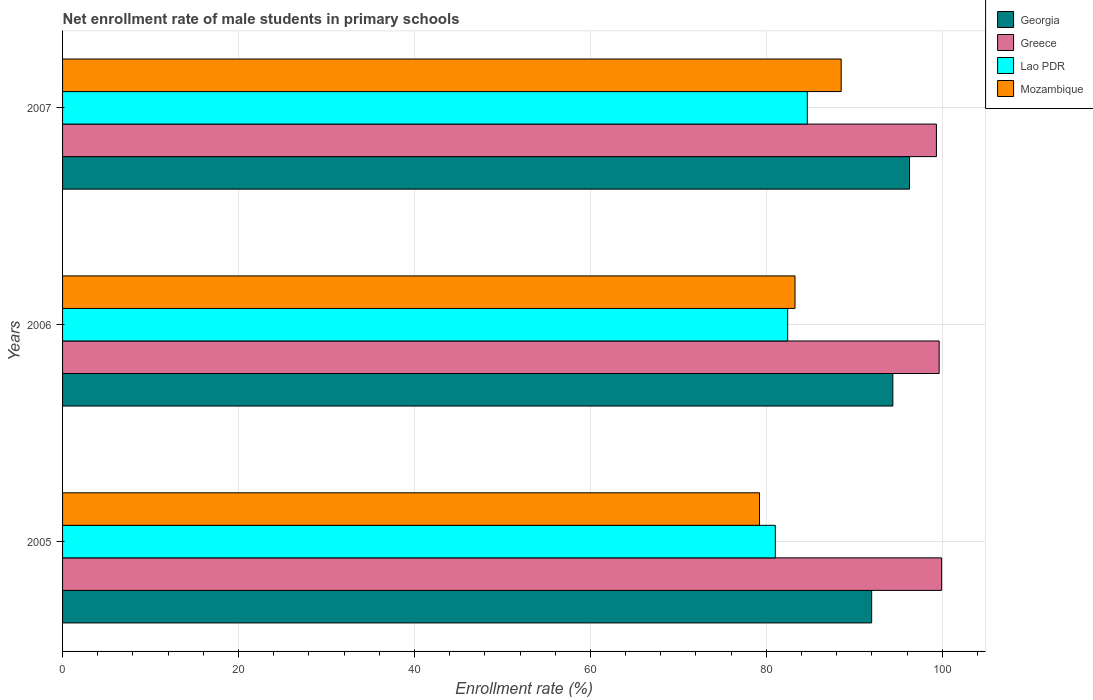How many different coloured bars are there?
Provide a succinct answer. 4. How many bars are there on the 1st tick from the bottom?
Your answer should be very brief. 4. What is the net enrollment rate of male students in primary schools in Mozambique in 2005?
Offer a very short reply. 79.22. Across all years, what is the maximum net enrollment rate of male students in primary schools in Lao PDR?
Your answer should be compact. 84.66. Across all years, what is the minimum net enrollment rate of male students in primary schools in Georgia?
Offer a very short reply. 91.97. In which year was the net enrollment rate of male students in primary schools in Lao PDR maximum?
Your answer should be very brief. 2007. In which year was the net enrollment rate of male students in primary schools in Mozambique minimum?
Your response must be concise. 2005. What is the total net enrollment rate of male students in primary schools in Mozambique in the graph?
Ensure brevity in your answer.  250.99. What is the difference between the net enrollment rate of male students in primary schools in Greece in 2005 and that in 2007?
Keep it short and to the point. 0.59. What is the difference between the net enrollment rate of male students in primary schools in Georgia in 2006 and the net enrollment rate of male students in primary schools in Lao PDR in 2007?
Your response must be concise. 9.72. What is the average net enrollment rate of male students in primary schools in Georgia per year?
Your answer should be compact. 94.21. In the year 2005, what is the difference between the net enrollment rate of male students in primary schools in Lao PDR and net enrollment rate of male students in primary schools in Greece?
Keep it short and to the point. -18.91. What is the ratio of the net enrollment rate of male students in primary schools in Mozambique in 2005 to that in 2007?
Keep it short and to the point. 0.9. Is the net enrollment rate of male students in primary schools in Mozambique in 2006 less than that in 2007?
Provide a succinct answer. Yes. What is the difference between the highest and the second highest net enrollment rate of male students in primary schools in Georgia?
Offer a very short reply. 1.9. What is the difference between the highest and the lowest net enrollment rate of male students in primary schools in Georgia?
Your answer should be very brief. 4.31. In how many years, is the net enrollment rate of male students in primary schools in Greece greater than the average net enrollment rate of male students in primary schools in Greece taken over all years?
Provide a short and direct response. 2. Is the sum of the net enrollment rate of male students in primary schools in Georgia in 2005 and 2006 greater than the maximum net enrollment rate of male students in primary schools in Lao PDR across all years?
Provide a succinct answer. Yes. What does the 1st bar from the top in 2007 represents?
Offer a very short reply. Mozambique. What does the 4th bar from the bottom in 2005 represents?
Your answer should be compact. Mozambique. How many bars are there?
Ensure brevity in your answer.  12. What is the difference between two consecutive major ticks on the X-axis?
Provide a succinct answer. 20. How many legend labels are there?
Offer a very short reply. 4. What is the title of the graph?
Your answer should be compact. Net enrollment rate of male students in primary schools. What is the label or title of the X-axis?
Provide a short and direct response. Enrollment rate (%). What is the Enrollment rate (%) of Georgia in 2005?
Offer a very short reply. 91.97. What is the Enrollment rate (%) of Greece in 2005?
Provide a succinct answer. 99.93. What is the Enrollment rate (%) in Lao PDR in 2005?
Give a very brief answer. 81.02. What is the Enrollment rate (%) of Mozambique in 2005?
Your answer should be compact. 79.22. What is the Enrollment rate (%) of Georgia in 2006?
Provide a succinct answer. 94.38. What is the Enrollment rate (%) of Greece in 2006?
Ensure brevity in your answer.  99.64. What is the Enrollment rate (%) of Lao PDR in 2006?
Give a very brief answer. 82.43. What is the Enrollment rate (%) of Mozambique in 2006?
Offer a very short reply. 83.26. What is the Enrollment rate (%) of Georgia in 2007?
Offer a very short reply. 96.28. What is the Enrollment rate (%) in Greece in 2007?
Your response must be concise. 99.33. What is the Enrollment rate (%) in Lao PDR in 2007?
Offer a very short reply. 84.66. What is the Enrollment rate (%) of Mozambique in 2007?
Your response must be concise. 88.51. Across all years, what is the maximum Enrollment rate (%) of Georgia?
Give a very brief answer. 96.28. Across all years, what is the maximum Enrollment rate (%) in Greece?
Make the answer very short. 99.93. Across all years, what is the maximum Enrollment rate (%) in Lao PDR?
Provide a succinct answer. 84.66. Across all years, what is the maximum Enrollment rate (%) in Mozambique?
Offer a very short reply. 88.51. Across all years, what is the minimum Enrollment rate (%) in Georgia?
Provide a succinct answer. 91.97. Across all years, what is the minimum Enrollment rate (%) of Greece?
Your answer should be compact. 99.33. Across all years, what is the minimum Enrollment rate (%) of Lao PDR?
Provide a succinct answer. 81.02. Across all years, what is the minimum Enrollment rate (%) in Mozambique?
Your answer should be compact. 79.22. What is the total Enrollment rate (%) in Georgia in the graph?
Your response must be concise. 282.63. What is the total Enrollment rate (%) in Greece in the graph?
Keep it short and to the point. 298.9. What is the total Enrollment rate (%) of Lao PDR in the graph?
Provide a short and direct response. 248.11. What is the total Enrollment rate (%) of Mozambique in the graph?
Offer a very short reply. 250.99. What is the difference between the Enrollment rate (%) in Georgia in 2005 and that in 2006?
Your answer should be very brief. -2.41. What is the difference between the Enrollment rate (%) of Greece in 2005 and that in 2006?
Offer a very short reply. 0.28. What is the difference between the Enrollment rate (%) of Lao PDR in 2005 and that in 2006?
Your answer should be very brief. -1.41. What is the difference between the Enrollment rate (%) in Mozambique in 2005 and that in 2006?
Your answer should be compact. -4.04. What is the difference between the Enrollment rate (%) of Georgia in 2005 and that in 2007?
Your answer should be compact. -4.31. What is the difference between the Enrollment rate (%) in Greece in 2005 and that in 2007?
Offer a terse response. 0.59. What is the difference between the Enrollment rate (%) in Lao PDR in 2005 and that in 2007?
Offer a terse response. -3.64. What is the difference between the Enrollment rate (%) in Mozambique in 2005 and that in 2007?
Your response must be concise. -9.28. What is the difference between the Enrollment rate (%) of Georgia in 2006 and that in 2007?
Give a very brief answer. -1.9. What is the difference between the Enrollment rate (%) in Greece in 2006 and that in 2007?
Your answer should be compact. 0.31. What is the difference between the Enrollment rate (%) of Lao PDR in 2006 and that in 2007?
Offer a terse response. -2.23. What is the difference between the Enrollment rate (%) of Mozambique in 2006 and that in 2007?
Provide a succinct answer. -5.25. What is the difference between the Enrollment rate (%) in Georgia in 2005 and the Enrollment rate (%) in Greece in 2006?
Your answer should be compact. -7.67. What is the difference between the Enrollment rate (%) of Georgia in 2005 and the Enrollment rate (%) of Lao PDR in 2006?
Give a very brief answer. 9.54. What is the difference between the Enrollment rate (%) in Georgia in 2005 and the Enrollment rate (%) in Mozambique in 2006?
Your answer should be compact. 8.71. What is the difference between the Enrollment rate (%) in Greece in 2005 and the Enrollment rate (%) in Lao PDR in 2006?
Offer a very short reply. 17.5. What is the difference between the Enrollment rate (%) of Greece in 2005 and the Enrollment rate (%) of Mozambique in 2006?
Provide a short and direct response. 16.67. What is the difference between the Enrollment rate (%) in Lao PDR in 2005 and the Enrollment rate (%) in Mozambique in 2006?
Make the answer very short. -2.24. What is the difference between the Enrollment rate (%) in Georgia in 2005 and the Enrollment rate (%) in Greece in 2007?
Your response must be concise. -7.36. What is the difference between the Enrollment rate (%) in Georgia in 2005 and the Enrollment rate (%) in Lao PDR in 2007?
Make the answer very short. 7.32. What is the difference between the Enrollment rate (%) of Georgia in 2005 and the Enrollment rate (%) of Mozambique in 2007?
Your response must be concise. 3.46. What is the difference between the Enrollment rate (%) of Greece in 2005 and the Enrollment rate (%) of Lao PDR in 2007?
Provide a short and direct response. 15.27. What is the difference between the Enrollment rate (%) in Greece in 2005 and the Enrollment rate (%) in Mozambique in 2007?
Give a very brief answer. 11.42. What is the difference between the Enrollment rate (%) of Lao PDR in 2005 and the Enrollment rate (%) of Mozambique in 2007?
Give a very brief answer. -7.49. What is the difference between the Enrollment rate (%) in Georgia in 2006 and the Enrollment rate (%) in Greece in 2007?
Keep it short and to the point. -4.95. What is the difference between the Enrollment rate (%) of Georgia in 2006 and the Enrollment rate (%) of Lao PDR in 2007?
Offer a very short reply. 9.72. What is the difference between the Enrollment rate (%) in Georgia in 2006 and the Enrollment rate (%) in Mozambique in 2007?
Provide a succinct answer. 5.87. What is the difference between the Enrollment rate (%) of Greece in 2006 and the Enrollment rate (%) of Lao PDR in 2007?
Provide a succinct answer. 14.99. What is the difference between the Enrollment rate (%) in Greece in 2006 and the Enrollment rate (%) in Mozambique in 2007?
Offer a terse response. 11.13. What is the difference between the Enrollment rate (%) in Lao PDR in 2006 and the Enrollment rate (%) in Mozambique in 2007?
Your response must be concise. -6.08. What is the average Enrollment rate (%) in Georgia per year?
Provide a short and direct response. 94.21. What is the average Enrollment rate (%) of Greece per year?
Ensure brevity in your answer.  99.63. What is the average Enrollment rate (%) in Lao PDR per year?
Offer a very short reply. 82.7. What is the average Enrollment rate (%) of Mozambique per year?
Offer a terse response. 83.66. In the year 2005, what is the difference between the Enrollment rate (%) in Georgia and Enrollment rate (%) in Greece?
Give a very brief answer. -7.95. In the year 2005, what is the difference between the Enrollment rate (%) in Georgia and Enrollment rate (%) in Lao PDR?
Your answer should be compact. 10.95. In the year 2005, what is the difference between the Enrollment rate (%) of Georgia and Enrollment rate (%) of Mozambique?
Give a very brief answer. 12.75. In the year 2005, what is the difference between the Enrollment rate (%) in Greece and Enrollment rate (%) in Lao PDR?
Your answer should be very brief. 18.91. In the year 2005, what is the difference between the Enrollment rate (%) in Greece and Enrollment rate (%) in Mozambique?
Provide a succinct answer. 20.7. In the year 2005, what is the difference between the Enrollment rate (%) in Lao PDR and Enrollment rate (%) in Mozambique?
Offer a terse response. 1.8. In the year 2006, what is the difference between the Enrollment rate (%) in Georgia and Enrollment rate (%) in Greece?
Make the answer very short. -5.26. In the year 2006, what is the difference between the Enrollment rate (%) in Georgia and Enrollment rate (%) in Lao PDR?
Your response must be concise. 11.95. In the year 2006, what is the difference between the Enrollment rate (%) of Georgia and Enrollment rate (%) of Mozambique?
Offer a very short reply. 11.12. In the year 2006, what is the difference between the Enrollment rate (%) of Greece and Enrollment rate (%) of Lao PDR?
Give a very brief answer. 17.22. In the year 2006, what is the difference between the Enrollment rate (%) of Greece and Enrollment rate (%) of Mozambique?
Make the answer very short. 16.38. In the year 2006, what is the difference between the Enrollment rate (%) in Lao PDR and Enrollment rate (%) in Mozambique?
Keep it short and to the point. -0.83. In the year 2007, what is the difference between the Enrollment rate (%) in Georgia and Enrollment rate (%) in Greece?
Your answer should be very brief. -3.06. In the year 2007, what is the difference between the Enrollment rate (%) of Georgia and Enrollment rate (%) of Lao PDR?
Your answer should be very brief. 11.62. In the year 2007, what is the difference between the Enrollment rate (%) in Georgia and Enrollment rate (%) in Mozambique?
Your answer should be very brief. 7.77. In the year 2007, what is the difference between the Enrollment rate (%) of Greece and Enrollment rate (%) of Lao PDR?
Your answer should be compact. 14.68. In the year 2007, what is the difference between the Enrollment rate (%) of Greece and Enrollment rate (%) of Mozambique?
Provide a succinct answer. 10.82. In the year 2007, what is the difference between the Enrollment rate (%) of Lao PDR and Enrollment rate (%) of Mozambique?
Provide a short and direct response. -3.85. What is the ratio of the Enrollment rate (%) of Georgia in 2005 to that in 2006?
Ensure brevity in your answer.  0.97. What is the ratio of the Enrollment rate (%) in Lao PDR in 2005 to that in 2006?
Make the answer very short. 0.98. What is the ratio of the Enrollment rate (%) of Mozambique in 2005 to that in 2006?
Offer a very short reply. 0.95. What is the ratio of the Enrollment rate (%) in Georgia in 2005 to that in 2007?
Your answer should be compact. 0.96. What is the ratio of the Enrollment rate (%) in Greece in 2005 to that in 2007?
Make the answer very short. 1.01. What is the ratio of the Enrollment rate (%) in Lao PDR in 2005 to that in 2007?
Your response must be concise. 0.96. What is the ratio of the Enrollment rate (%) of Mozambique in 2005 to that in 2007?
Keep it short and to the point. 0.9. What is the ratio of the Enrollment rate (%) of Georgia in 2006 to that in 2007?
Your answer should be compact. 0.98. What is the ratio of the Enrollment rate (%) of Lao PDR in 2006 to that in 2007?
Provide a succinct answer. 0.97. What is the ratio of the Enrollment rate (%) in Mozambique in 2006 to that in 2007?
Provide a short and direct response. 0.94. What is the difference between the highest and the second highest Enrollment rate (%) in Georgia?
Give a very brief answer. 1.9. What is the difference between the highest and the second highest Enrollment rate (%) in Greece?
Your answer should be very brief. 0.28. What is the difference between the highest and the second highest Enrollment rate (%) of Lao PDR?
Provide a succinct answer. 2.23. What is the difference between the highest and the second highest Enrollment rate (%) in Mozambique?
Make the answer very short. 5.25. What is the difference between the highest and the lowest Enrollment rate (%) in Georgia?
Your response must be concise. 4.31. What is the difference between the highest and the lowest Enrollment rate (%) of Greece?
Provide a succinct answer. 0.59. What is the difference between the highest and the lowest Enrollment rate (%) in Lao PDR?
Your answer should be compact. 3.64. What is the difference between the highest and the lowest Enrollment rate (%) in Mozambique?
Offer a very short reply. 9.28. 